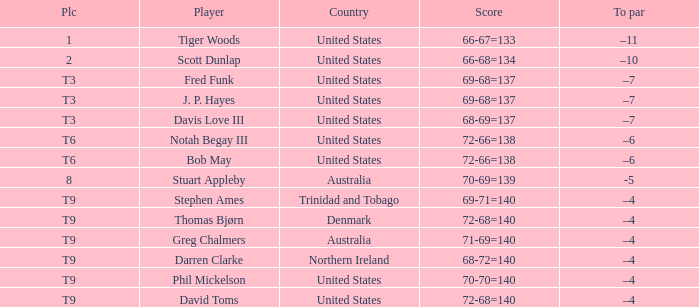What country is Darren Clarke from? Northern Ireland. 